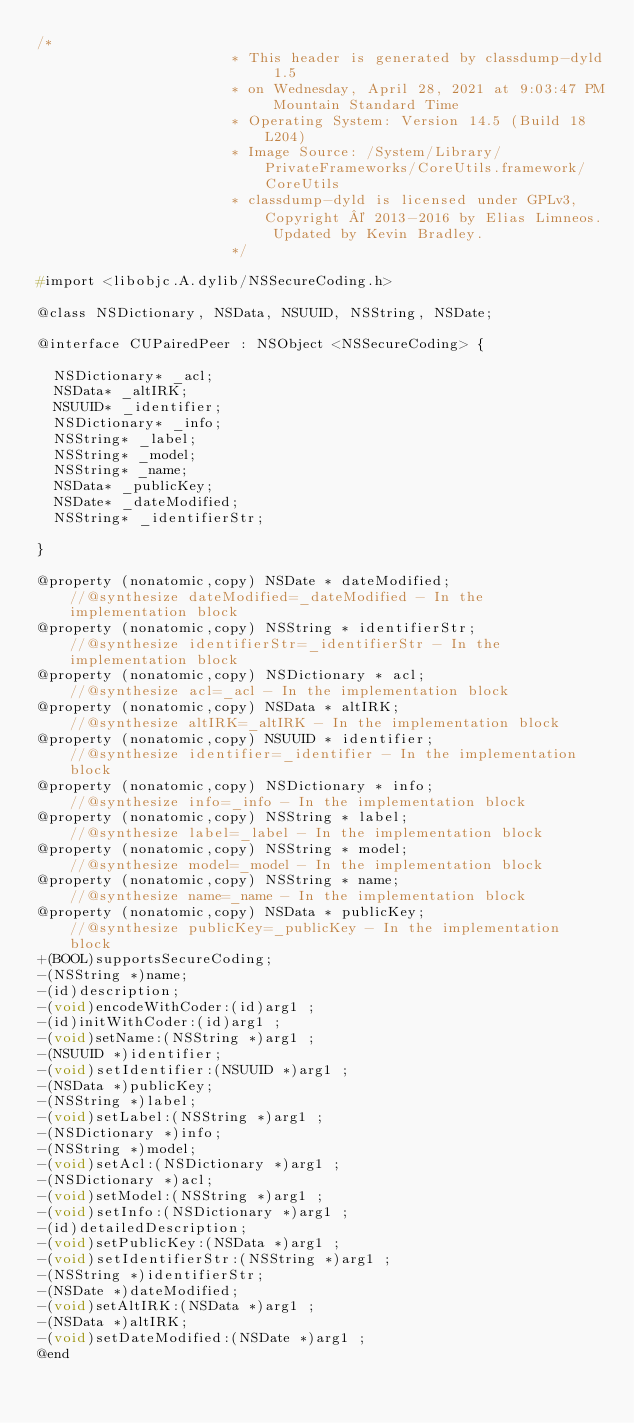<code> <loc_0><loc_0><loc_500><loc_500><_C_>/*
                       * This header is generated by classdump-dyld 1.5
                       * on Wednesday, April 28, 2021 at 9:03:47 PM Mountain Standard Time
                       * Operating System: Version 14.5 (Build 18L204)
                       * Image Source: /System/Library/PrivateFrameworks/CoreUtils.framework/CoreUtils
                       * classdump-dyld is licensed under GPLv3, Copyright © 2013-2016 by Elias Limneos. Updated by Kevin Bradley.
                       */

#import <libobjc.A.dylib/NSSecureCoding.h>

@class NSDictionary, NSData, NSUUID, NSString, NSDate;

@interface CUPairedPeer : NSObject <NSSecureCoding> {

	NSDictionary* _acl;
	NSData* _altIRK;
	NSUUID* _identifier;
	NSDictionary* _info;
	NSString* _label;
	NSString* _model;
	NSString* _name;
	NSData* _publicKey;
	NSDate* _dateModified;
	NSString* _identifierStr;

}

@property (nonatomic,copy) NSDate * dateModified;                 //@synthesize dateModified=_dateModified - In the implementation block
@property (nonatomic,copy) NSString * identifierStr;              //@synthesize identifierStr=_identifierStr - In the implementation block
@property (nonatomic,copy) NSDictionary * acl;                    //@synthesize acl=_acl - In the implementation block
@property (nonatomic,copy) NSData * altIRK;                       //@synthesize altIRK=_altIRK - In the implementation block
@property (nonatomic,copy) NSUUID * identifier;                   //@synthesize identifier=_identifier - In the implementation block
@property (nonatomic,copy) NSDictionary * info;                   //@synthesize info=_info - In the implementation block
@property (nonatomic,copy) NSString * label;                      //@synthesize label=_label - In the implementation block
@property (nonatomic,copy) NSString * model;                      //@synthesize model=_model - In the implementation block
@property (nonatomic,copy) NSString * name;                       //@synthesize name=_name - In the implementation block
@property (nonatomic,copy) NSData * publicKey;                    //@synthesize publicKey=_publicKey - In the implementation block
+(BOOL)supportsSecureCoding;
-(NSString *)name;
-(id)description;
-(void)encodeWithCoder:(id)arg1 ;
-(id)initWithCoder:(id)arg1 ;
-(void)setName:(NSString *)arg1 ;
-(NSUUID *)identifier;
-(void)setIdentifier:(NSUUID *)arg1 ;
-(NSData *)publicKey;
-(NSString *)label;
-(void)setLabel:(NSString *)arg1 ;
-(NSDictionary *)info;
-(NSString *)model;
-(void)setAcl:(NSDictionary *)arg1 ;
-(NSDictionary *)acl;
-(void)setModel:(NSString *)arg1 ;
-(void)setInfo:(NSDictionary *)arg1 ;
-(id)detailedDescription;
-(void)setPublicKey:(NSData *)arg1 ;
-(void)setIdentifierStr:(NSString *)arg1 ;
-(NSString *)identifierStr;
-(NSDate *)dateModified;
-(void)setAltIRK:(NSData *)arg1 ;
-(NSData *)altIRK;
-(void)setDateModified:(NSDate *)arg1 ;
@end

</code> 